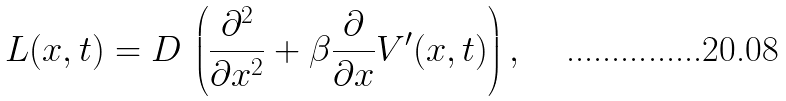Convert formula to latex. <formula><loc_0><loc_0><loc_500><loc_500>L ( x , t ) = D \, \left ( \frac { \partial ^ { 2 } } { \partial x ^ { 2 } } + \beta \frac { \partial } { \partial x } V ^ { \prime } ( x , t ) \right ) ,</formula> 